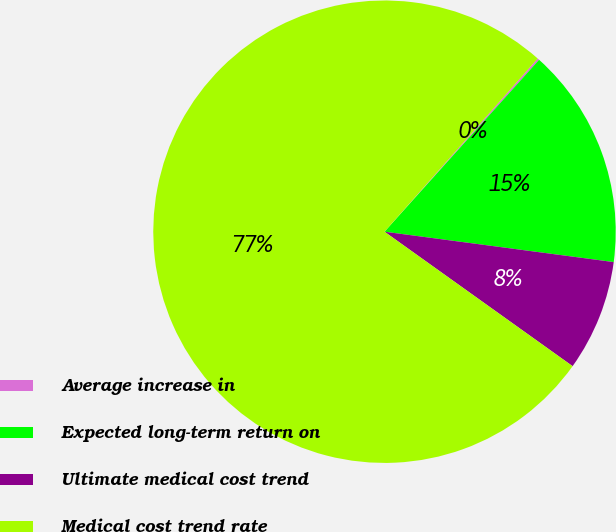<chart> <loc_0><loc_0><loc_500><loc_500><pie_chart><fcel>Average increase in<fcel>Expected long-term return on<fcel>Ultimate medical cost trend<fcel>Medical cost trend rate<nl><fcel>0.13%<fcel>15.44%<fcel>7.78%<fcel>76.65%<nl></chart> 